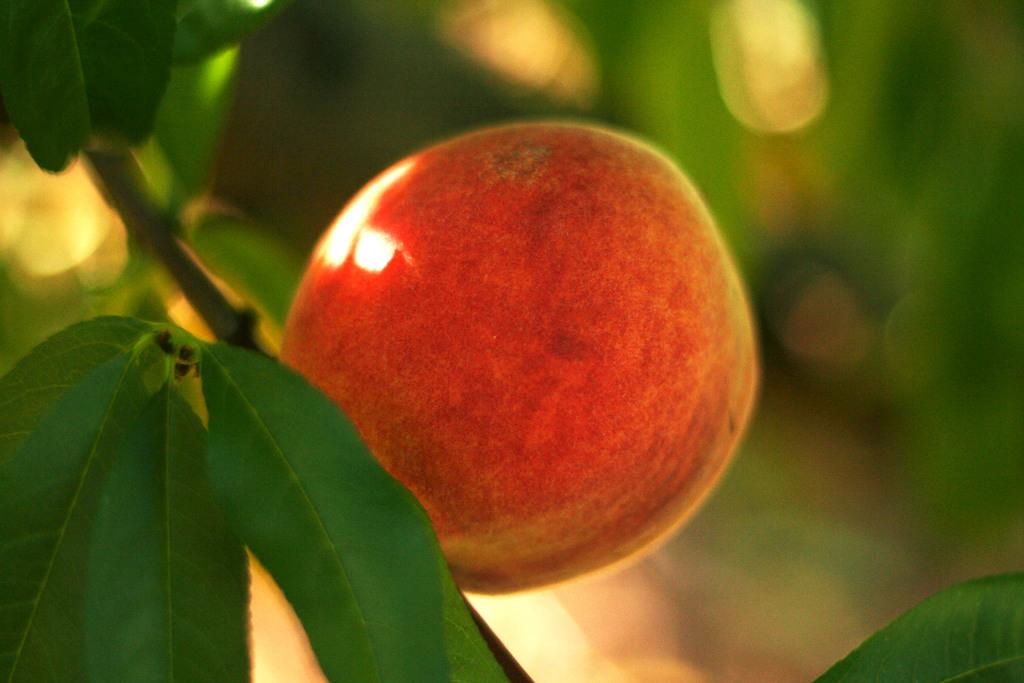What is the main subject in the foreground of the image? There is a fruit in the foreground of the image. Can you describe the background of the image? The background of the image is blurred. What type of chain can be seen hanging from the fruit in the image? There is no chain present in the image; it only features a fruit in the foreground. 